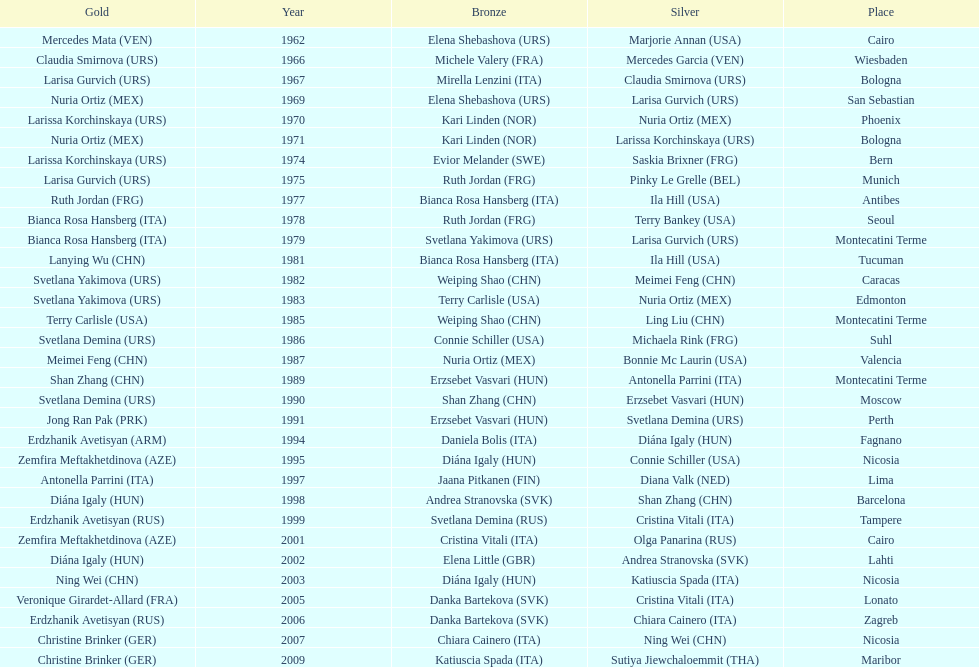Has china or mexico garnered more gold medals in their history? China. Could you parse the entire table as a dict? {'header': ['Gold', 'Year', 'Bronze', 'Silver', 'Place'], 'rows': [['Mercedes Mata\xa0(VEN)', '1962', 'Elena Shebashova\xa0(URS)', 'Marjorie Annan\xa0(USA)', 'Cairo'], ['Claudia Smirnova\xa0(URS)', '1966', 'Michele Valery\xa0(FRA)', 'Mercedes Garcia\xa0(VEN)', 'Wiesbaden'], ['Larisa Gurvich\xa0(URS)', '1967', 'Mirella Lenzini\xa0(ITA)', 'Claudia Smirnova\xa0(URS)', 'Bologna'], ['Nuria Ortiz\xa0(MEX)', '1969', 'Elena Shebashova\xa0(URS)', 'Larisa Gurvich\xa0(URS)', 'San Sebastian'], ['Larissa Korchinskaya\xa0(URS)', '1970', 'Kari Linden\xa0(NOR)', 'Nuria Ortiz\xa0(MEX)', 'Phoenix'], ['Nuria Ortiz\xa0(MEX)', '1971', 'Kari Linden\xa0(NOR)', 'Larissa Korchinskaya\xa0(URS)', 'Bologna'], ['Larissa Korchinskaya\xa0(URS)', '1974', 'Evior Melander\xa0(SWE)', 'Saskia Brixner\xa0(FRG)', 'Bern'], ['Larisa Gurvich\xa0(URS)', '1975', 'Ruth Jordan\xa0(FRG)', 'Pinky Le Grelle\xa0(BEL)', 'Munich'], ['Ruth Jordan\xa0(FRG)', '1977', 'Bianca Rosa Hansberg\xa0(ITA)', 'Ila Hill\xa0(USA)', 'Antibes'], ['Bianca Rosa Hansberg\xa0(ITA)', '1978', 'Ruth Jordan\xa0(FRG)', 'Terry Bankey\xa0(USA)', 'Seoul'], ['Bianca Rosa Hansberg\xa0(ITA)', '1979', 'Svetlana Yakimova\xa0(URS)', 'Larisa Gurvich\xa0(URS)', 'Montecatini Terme'], ['Lanying Wu\xa0(CHN)', '1981', 'Bianca Rosa Hansberg\xa0(ITA)', 'Ila Hill\xa0(USA)', 'Tucuman'], ['Svetlana Yakimova\xa0(URS)', '1982', 'Weiping Shao\xa0(CHN)', 'Meimei Feng\xa0(CHN)', 'Caracas'], ['Svetlana Yakimova\xa0(URS)', '1983', 'Terry Carlisle\xa0(USA)', 'Nuria Ortiz\xa0(MEX)', 'Edmonton'], ['Terry Carlisle\xa0(USA)', '1985', 'Weiping Shao\xa0(CHN)', 'Ling Liu\xa0(CHN)', 'Montecatini Terme'], ['Svetlana Demina\xa0(URS)', '1986', 'Connie Schiller\xa0(USA)', 'Michaela Rink\xa0(FRG)', 'Suhl'], ['Meimei Feng\xa0(CHN)', '1987', 'Nuria Ortiz\xa0(MEX)', 'Bonnie Mc Laurin\xa0(USA)', 'Valencia'], ['Shan Zhang\xa0(CHN)', '1989', 'Erzsebet Vasvari\xa0(HUN)', 'Antonella Parrini\xa0(ITA)', 'Montecatini Terme'], ['Svetlana Demina\xa0(URS)', '1990', 'Shan Zhang\xa0(CHN)', 'Erzsebet Vasvari\xa0(HUN)', 'Moscow'], ['Jong Ran Pak\xa0(PRK)', '1991', 'Erzsebet Vasvari\xa0(HUN)', 'Svetlana Demina\xa0(URS)', 'Perth'], ['Erdzhanik Avetisyan\xa0(ARM)', '1994', 'Daniela Bolis\xa0(ITA)', 'Diána Igaly\xa0(HUN)', 'Fagnano'], ['Zemfira Meftakhetdinova\xa0(AZE)', '1995', 'Diána Igaly\xa0(HUN)', 'Connie Schiller\xa0(USA)', 'Nicosia'], ['Antonella Parrini\xa0(ITA)', '1997', 'Jaana Pitkanen\xa0(FIN)', 'Diana Valk\xa0(NED)', 'Lima'], ['Diána Igaly\xa0(HUN)', '1998', 'Andrea Stranovska\xa0(SVK)', 'Shan Zhang\xa0(CHN)', 'Barcelona'], ['Erdzhanik Avetisyan\xa0(RUS)', '1999', 'Svetlana Demina\xa0(RUS)', 'Cristina Vitali\xa0(ITA)', 'Tampere'], ['Zemfira Meftakhetdinova\xa0(AZE)', '2001', 'Cristina Vitali\xa0(ITA)', 'Olga Panarina\xa0(RUS)', 'Cairo'], ['Diána Igaly\xa0(HUN)', '2002', 'Elena Little\xa0(GBR)', 'Andrea Stranovska\xa0(SVK)', 'Lahti'], ['Ning Wei\xa0(CHN)', '2003', 'Diána Igaly\xa0(HUN)', 'Katiuscia Spada\xa0(ITA)', 'Nicosia'], ['Veronique Girardet-Allard\xa0(FRA)', '2005', 'Danka Bartekova\xa0(SVK)', 'Cristina Vitali\xa0(ITA)', 'Lonato'], ['Erdzhanik Avetisyan\xa0(RUS)', '2006', 'Danka Bartekova\xa0(SVK)', 'Chiara Cainero\xa0(ITA)', 'Zagreb'], ['Christine Brinker\xa0(GER)', '2007', 'Chiara Cainero\xa0(ITA)', 'Ning Wei\xa0(CHN)', 'Nicosia'], ['Christine Brinker\xa0(GER)', '2009', 'Katiuscia Spada\xa0(ITA)', 'Sutiya Jiewchaloemmit\xa0(THA)', 'Maribor']]} 